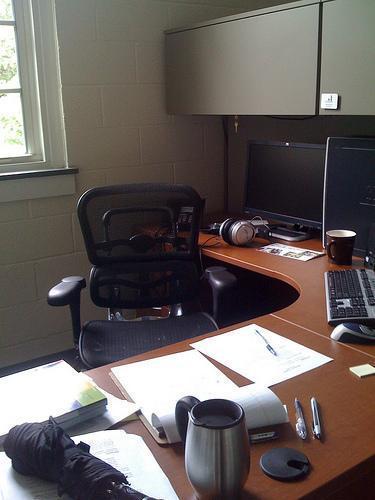How many pens are on the desk?
Give a very brief answer. 3. 